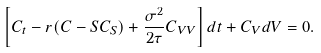<formula> <loc_0><loc_0><loc_500><loc_500>\left [ C _ { t } - r ( C - S C _ { S } ) + \frac { \sigma ^ { 2 } } { 2 \tau } C _ { V V } \right ] d t + C _ { V } d V = 0 .</formula> 